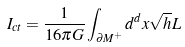<formula> <loc_0><loc_0><loc_500><loc_500>I _ { c t } = \frac { 1 } { 1 6 \pi G } \int _ { \partial M ^ { + } } d ^ { d } x \sqrt { h } L</formula> 